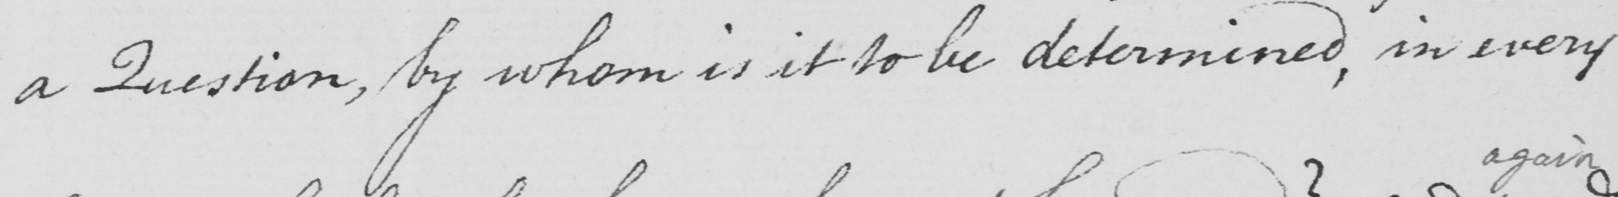What is written in this line of handwriting? a Question , by whom is it to be determined , in every 